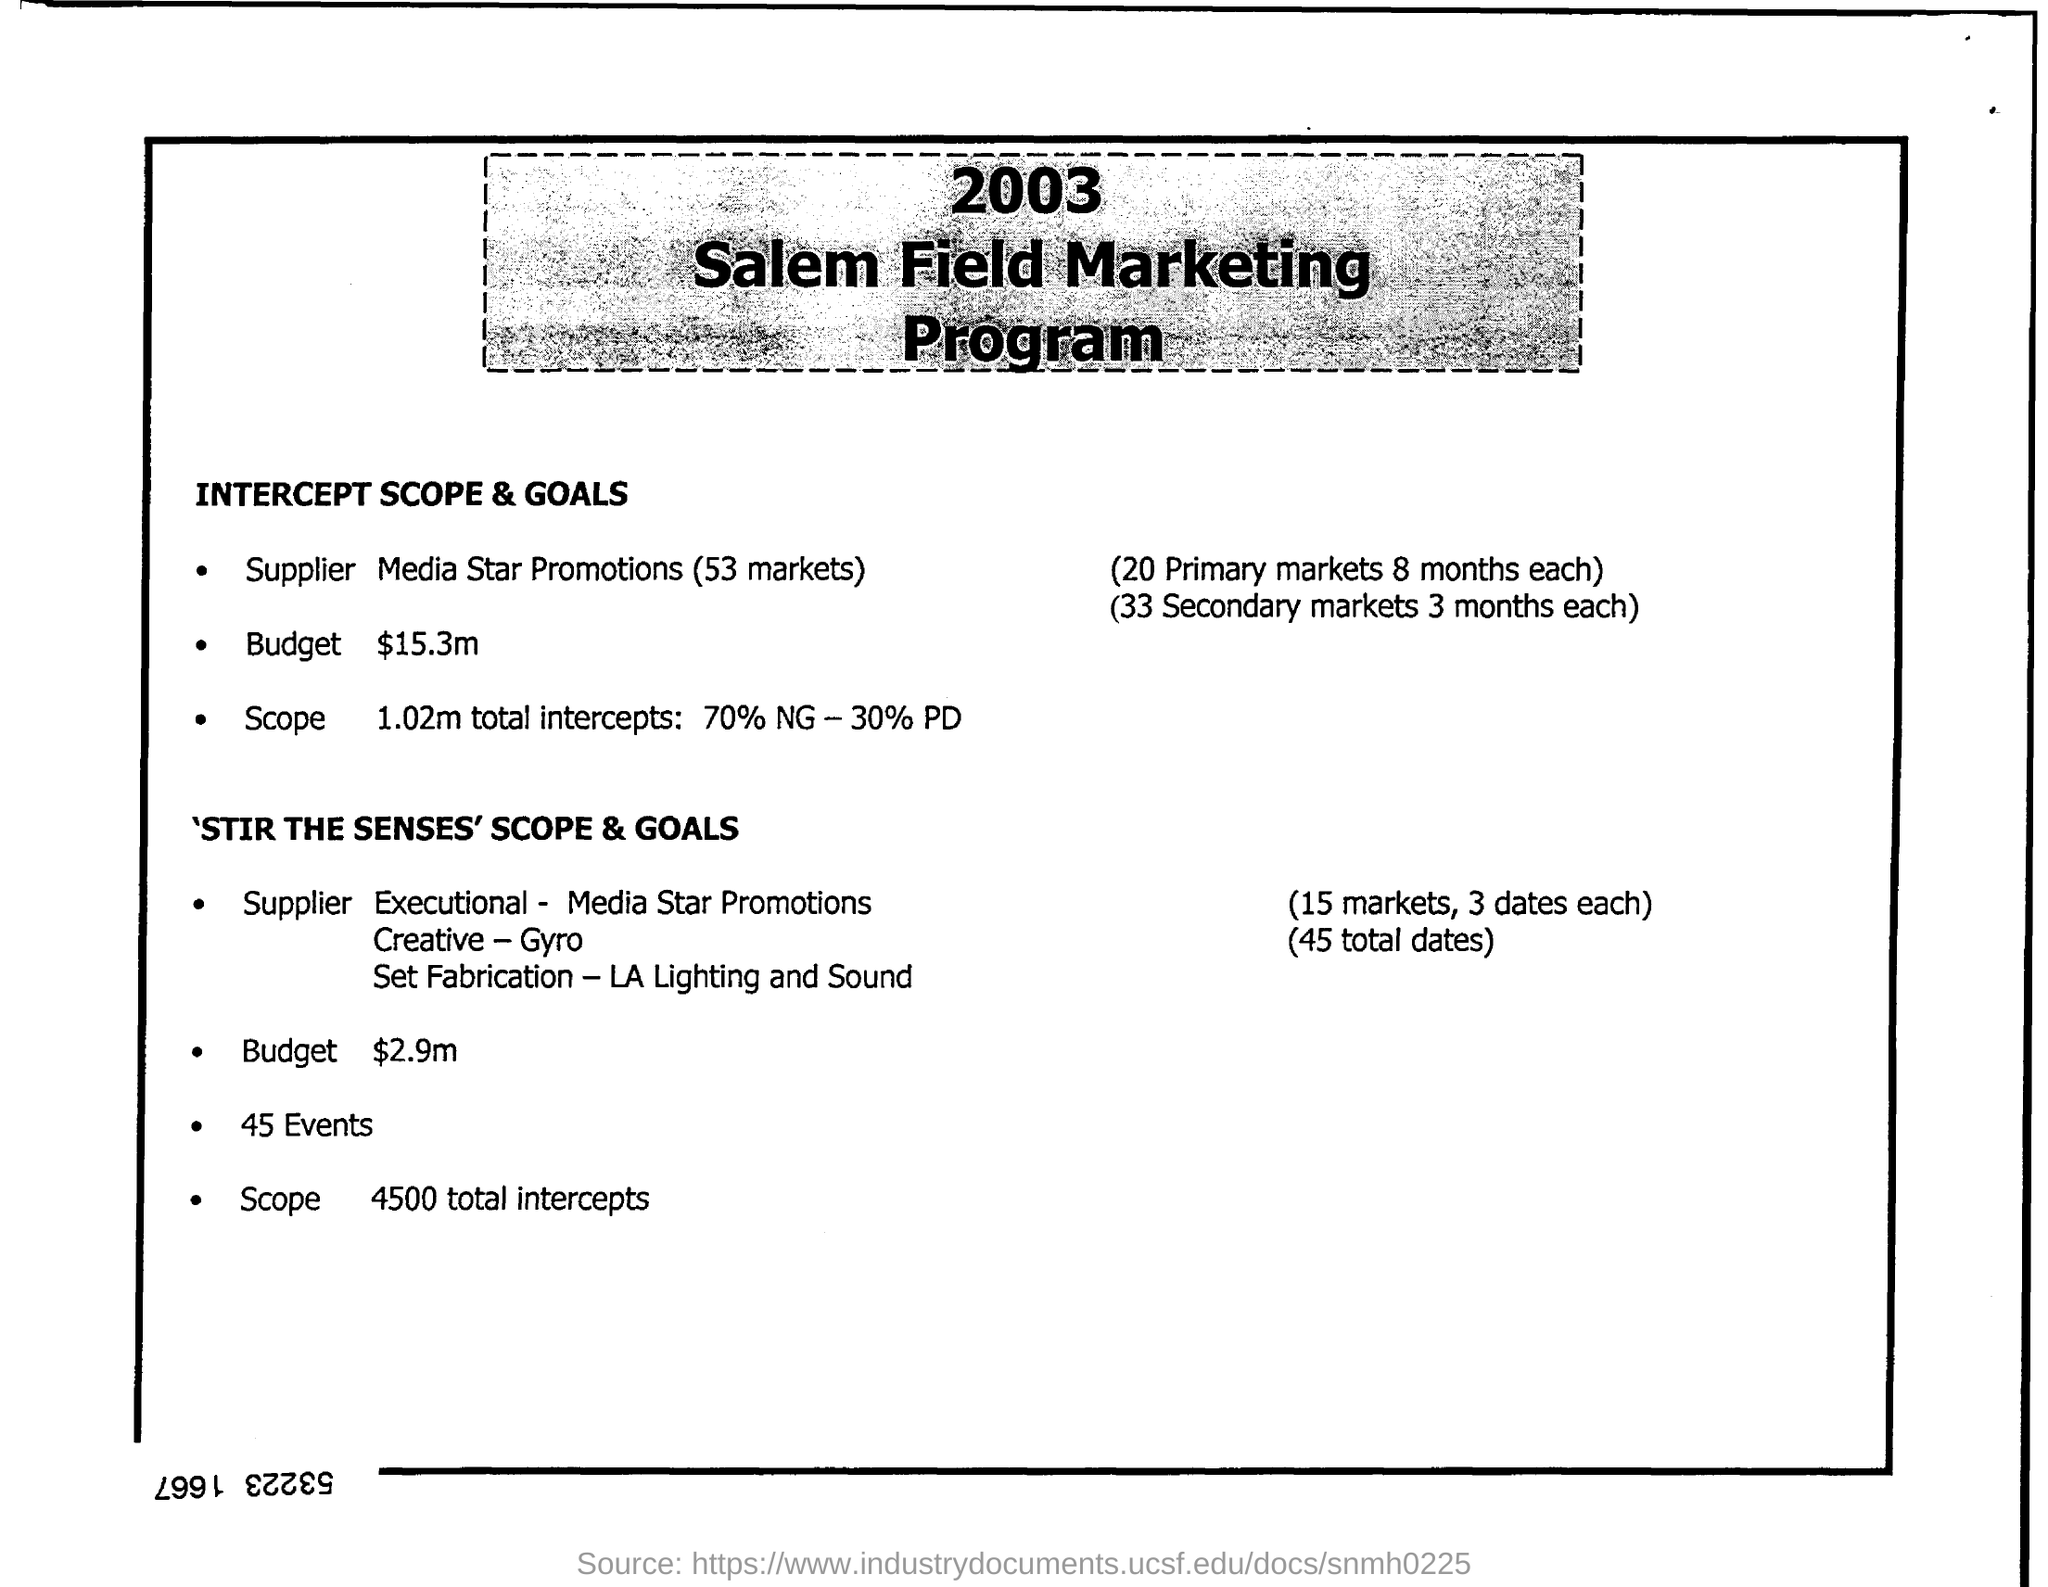What is the name of the program ?
Your response must be concise. 2003 Salem Field Marketing Program . 